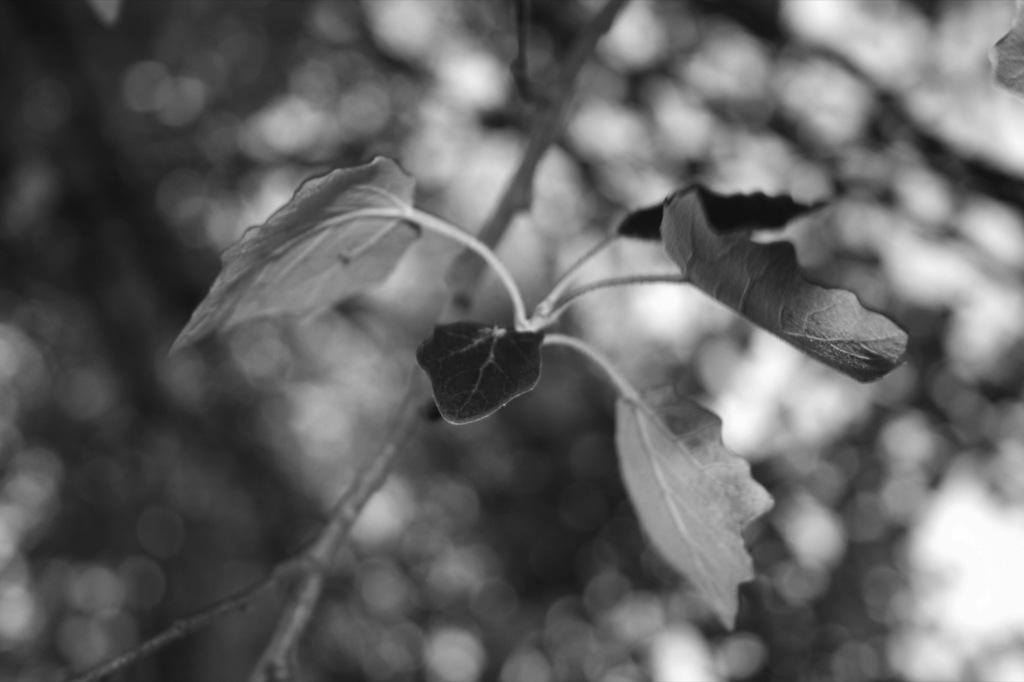What is the color scheme of the image? The image is black and white. What can be observed about the background of the image? The background of the image is blurred. What is the main subject in the middle of the image? There is a plant in the middle of the image. What type of soap is being used to clean the plant in the image? There is no soap or cleaning activity present in the image; it features a plant in a black and white, blurred background. 